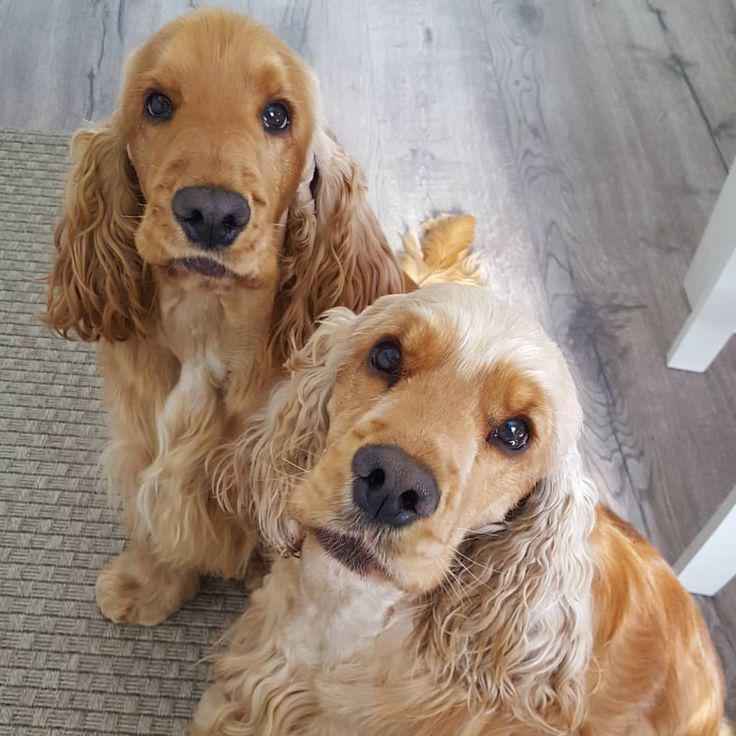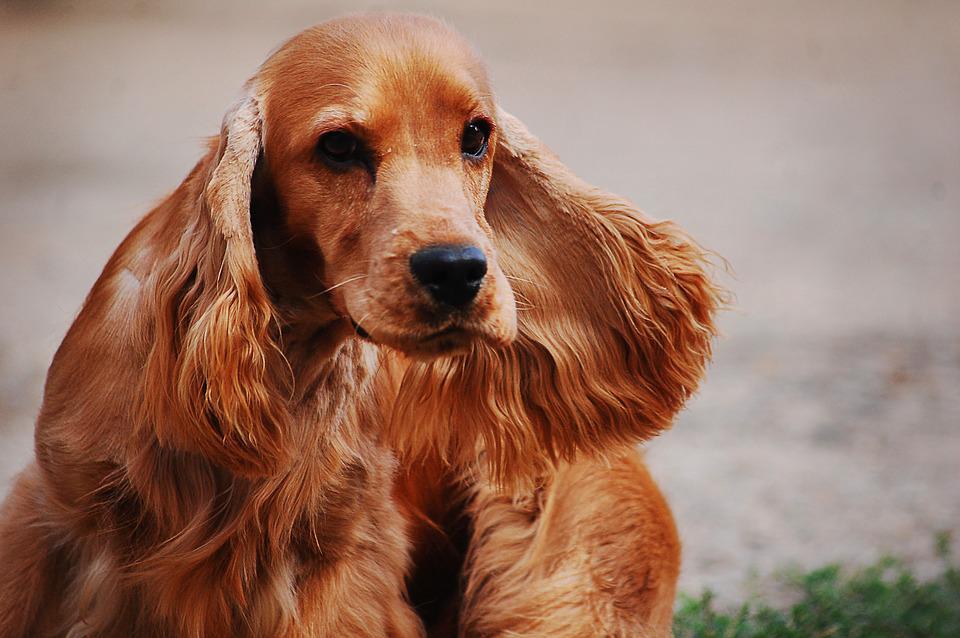The first image is the image on the left, the second image is the image on the right. Evaluate the accuracy of this statement regarding the images: "There is at least one dog indoors in the image on the left.". Is it true? Answer yes or no. Yes. 